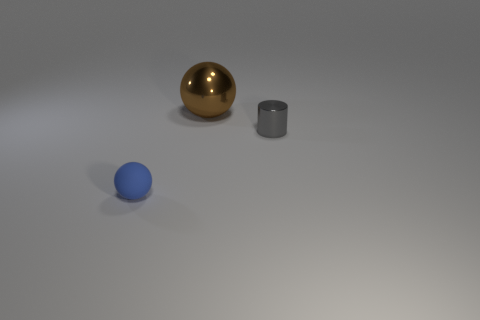There is a metallic object in front of the large metallic sphere; does it have the same size as the object that is behind the tiny gray cylinder?
Ensure brevity in your answer.  No. What number of objects are large brown things or red shiny cylinders?
Keep it short and to the point. 1. There is a tiny gray shiny object; what shape is it?
Your response must be concise. Cylinder. What is the size of the other object that is the same shape as the blue rubber object?
Your answer should be very brief. Large. Are there any other things that are the same material as the blue object?
Give a very brief answer. No. What size is the sphere behind the tiny object behind the tiny blue matte thing?
Keep it short and to the point. Large. Is the number of shiny things that are on the right side of the big brown ball the same as the number of blue spheres?
Make the answer very short. Yes. How many other objects are there of the same color as the cylinder?
Keep it short and to the point. 0. Is the number of tiny blue spheres that are in front of the small blue rubber object less than the number of big matte things?
Offer a very short reply. No. Are there any blue balls of the same size as the gray metallic cylinder?
Offer a very short reply. Yes. 